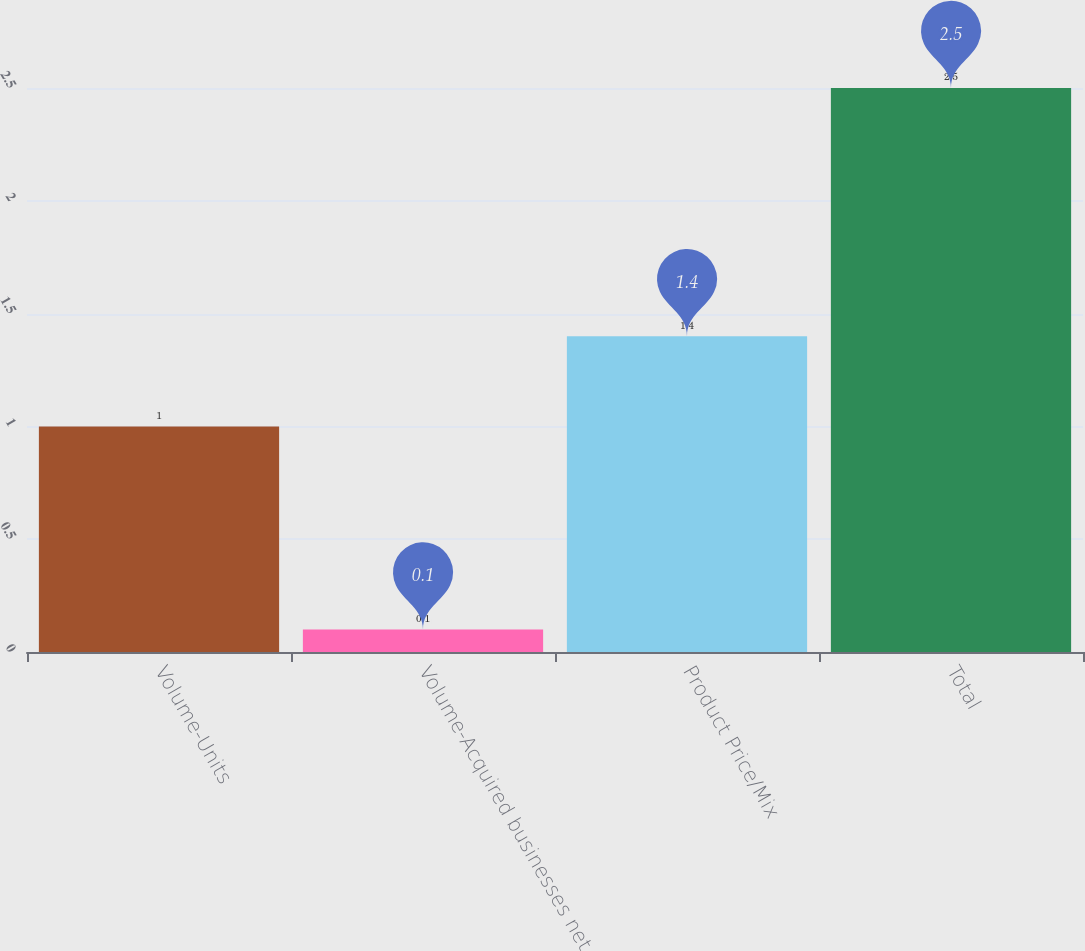Convert chart. <chart><loc_0><loc_0><loc_500><loc_500><bar_chart><fcel>Volume-Units<fcel>Volume-Acquired businesses net<fcel>Product Price/Mix<fcel>Total<nl><fcel>1<fcel>0.1<fcel>1.4<fcel>2.5<nl></chart> 